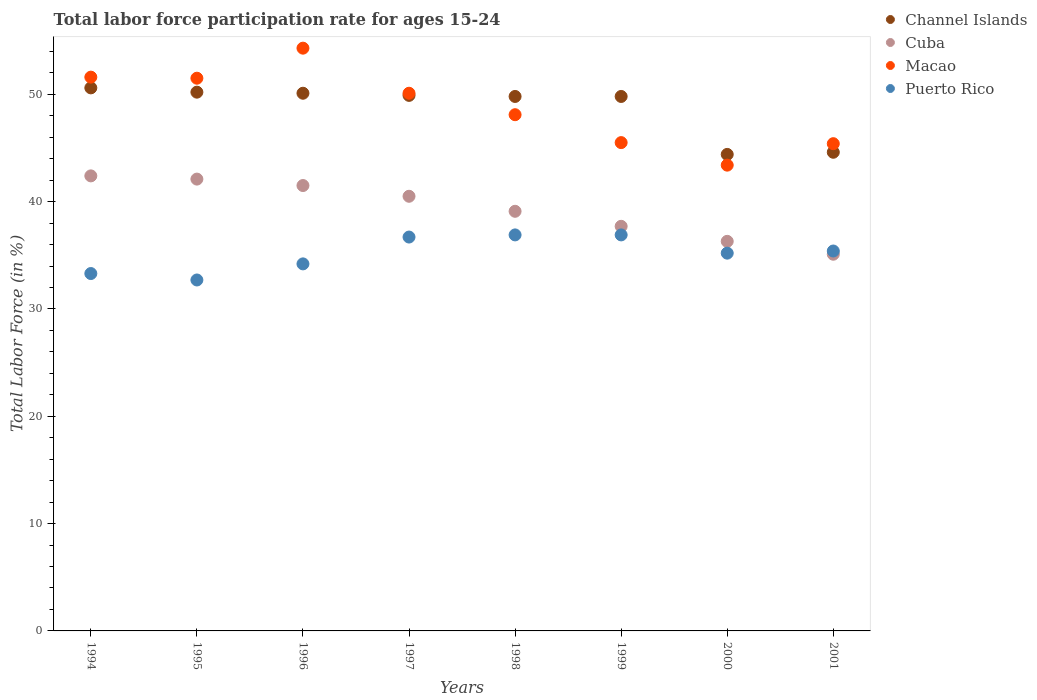Is the number of dotlines equal to the number of legend labels?
Make the answer very short. Yes. What is the labor force participation rate in Puerto Rico in 2001?
Provide a short and direct response. 35.4. Across all years, what is the maximum labor force participation rate in Cuba?
Your answer should be very brief. 42.4. Across all years, what is the minimum labor force participation rate in Macao?
Provide a short and direct response. 43.4. What is the total labor force participation rate in Channel Islands in the graph?
Offer a terse response. 389.4. What is the difference between the labor force participation rate in Macao in 1995 and that in 1997?
Provide a short and direct response. 1.4. What is the difference between the labor force participation rate in Channel Islands in 2000 and the labor force participation rate in Cuba in 2001?
Your answer should be very brief. 9.3. What is the average labor force participation rate in Cuba per year?
Provide a succinct answer. 39.34. In how many years, is the labor force participation rate in Puerto Rico greater than 38 %?
Ensure brevity in your answer.  0. What is the ratio of the labor force participation rate in Channel Islands in 1994 to that in 1997?
Offer a very short reply. 1.01. Is the difference between the labor force participation rate in Cuba in 1995 and 1996 greater than the difference between the labor force participation rate in Macao in 1995 and 1996?
Ensure brevity in your answer.  Yes. What is the difference between the highest and the lowest labor force participation rate in Puerto Rico?
Give a very brief answer. 4.2. Is it the case that in every year, the sum of the labor force participation rate in Macao and labor force participation rate in Puerto Rico  is greater than the sum of labor force participation rate in Channel Islands and labor force participation rate in Cuba?
Offer a terse response. No. Does the labor force participation rate in Cuba monotonically increase over the years?
Make the answer very short. No. Is the labor force participation rate in Cuba strictly less than the labor force participation rate in Channel Islands over the years?
Your answer should be very brief. Yes. How many dotlines are there?
Ensure brevity in your answer.  4. How many years are there in the graph?
Your response must be concise. 8. Does the graph contain any zero values?
Provide a short and direct response. No. What is the title of the graph?
Ensure brevity in your answer.  Total labor force participation rate for ages 15-24. What is the label or title of the Y-axis?
Ensure brevity in your answer.  Total Labor Force (in %). What is the Total Labor Force (in %) in Channel Islands in 1994?
Make the answer very short. 50.6. What is the Total Labor Force (in %) in Cuba in 1994?
Your answer should be compact. 42.4. What is the Total Labor Force (in %) in Macao in 1994?
Give a very brief answer. 51.6. What is the Total Labor Force (in %) of Puerto Rico in 1994?
Keep it short and to the point. 33.3. What is the Total Labor Force (in %) in Channel Islands in 1995?
Offer a very short reply. 50.2. What is the Total Labor Force (in %) of Cuba in 1995?
Your answer should be very brief. 42.1. What is the Total Labor Force (in %) of Macao in 1995?
Ensure brevity in your answer.  51.5. What is the Total Labor Force (in %) in Puerto Rico in 1995?
Ensure brevity in your answer.  32.7. What is the Total Labor Force (in %) of Channel Islands in 1996?
Provide a succinct answer. 50.1. What is the Total Labor Force (in %) in Cuba in 1996?
Offer a very short reply. 41.5. What is the Total Labor Force (in %) in Macao in 1996?
Ensure brevity in your answer.  54.3. What is the Total Labor Force (in %) of Puerto Rico in 1996?
Offer a very short reply. 34.2. What is the Total Labor Force (in %) of Channel Islands in 1997?
Your response must be concise. 49.9. What is the Total Labor Force (in %) of Cuba in 1997?
Make the answer very short. 40.5. What is the Total Labor Force (in %) in Macao in 1997?
Provide a succinct answer. 50.1. What is the Total Labor Force (in %) in Puerto Rico in 1997?
Your response must be concise. 36.7. What is the Total Labor Force (in %) in Channel Islands in 1998?
Give a very brief answer. 49.8. What is the Total Labor Force (in %) of Cuba in 1998?
Give a very brief answer. 39.1. What is the Total Labor Force (in %) of Macao in 1998?
Provide a succinct answer. 48.1. What is the Total Labor Force (in %) in Puerto Rico in 1998?
Provide a short and direct response. 36.9. What is the Total Labor Force (in %) in Channel Islands in 1999?
Your answer should be very brief. 49.8. What is the Total Labor Force (in %) in Cuba in 1999?
Ensure brevity in your answer.  37.7. What is the Total Labor Force (in %) of Macao in 1999?
Offer a terse response. 45.5. What is the Total Labor Force (in %) in Puerto Rico in 1999?
Ensure brevity in your answer.  36.9. What is the Total Labor Force (in %) of Channel Islands in 2000?
Ensure brevity in your answer.  44.4. What is the Total Labor Force (in %) in Cuba in 2000?
Your answer should be very brief. 36.3. What is the Total Labor Force (in %) of Macao in 2000?
Your response must be concise. 43.4. What is the Total Labor Force (in %) of Puerto Rico in 2000?
Provide a short and direct response. 35.2. What is the Total Labor Force (in %) of Channel Islands in 2001?
Provide a short and direct response. 44.6. What is the Total Labor Force (in %) of Cuba in 2001?
Ensure brevity in your answer.  35.1. What is the Total Labor Force (in %) of Macao in 2001?
Your answer should be compact. 45.4. What is the Total Labor Force (in %) in Puerto Rico in 2001?
Keep it short and to the point. 35.4. Across all years, what is the maximum Total Labor Force (in %) in Channel Islands?
Make the answer very short. 50.6. Across all years, what is the maximum Total Labor Force (in %) in Cuba?
Give a very brief answer. 42.4. Across all years, what is the maximum Total Labor Force (in %) of Macao?
Your answer should be compact. 54.3. Across all years, what is the maximum Total Labor Force (in %) in Puerto Rico?
Provide a short and direct response. 36.9. Across all years, what is the minimum Total Labor Force (in %) of Channel Islands?
Your response must be concise. 44.4. Across all years, what is the minimum Total Labor Force (in %) of Cuba?
Give a very brief answer. 35.1. Across all years, what is the minimum Total Labor Force (in %) of Macao?
Your answer should be compact. 43.4. Across all years, what is the minimum Total Labor Force (in %) in Puerto Rico?
Your response must be concise. 32.7. What is the total Total Labor Force (in %) of Channel Islands in the graph?
Your answer should be compact. 389.4. What is the total Total Labor Force (in %) in Cuba in the graph?
Your answer should be very brief. 314.7. What is the total Total Labor Force (in %) in Macao in the graph?
Your answer should be compact. 389.9. What is the total Total Labor Force (in %) in Puerto Rico in the graph?
Offer a terse response. 281.3. What is the difference between the Total Labor Force (in %) in Channel Islands in 1994 and that in 1995?
Give a very brief answer. 0.4. What is the difference between the Total Labor Force (in %) in Cuba in 1994 and that in 1995?
Your response must be concise. 0.3. What is the difference between the Total Labor Force (in %) of Puerto Rico in 1994 and that in 1995?
Your response must be concise. 0.6. What is the difference between the Total Labor Force (in %) of Cuba in 1994 and that in 1996?
Give a very brief answer. 0.9. What is the difference between the Total Labor Force (in %) of Macao in 1994 and that in 1996?
Your answer should be very brief. -2.7. What is the difference between the Total Labor Force (in %) in Puerto Rico in 1994 and that in 1996?
Your answer should be compact. -0.9. What is the difference between the Total Labor Force (in %) of Cuba in 1994 and that in 1997?
Keep it short and to the point. 1.9. What is the difference between the Total Labor Force (in %) in Puerto Rico in 1994 and that in 1997?
Your answer should be very brief. -3.4. What is the difference between the Total Labor Force (in %) in Channel Islands in 1994 and that in 1998?
Offer a terse response. 0.8. What is the difference between the Total Labor Force (in %) of Cuba in 1994 and that in 1998?
Make the answer very short. 3.3. What is the difference between the Total Labor Force (in %) in Macao in 1994 and that in 1998?
Make the answer very short. 3.5. What is the difference between the Total Labor Force (in %) in Cuba in 1994 and that in 1999?
Your response must be concise. 4.7. What is the difference between the Total Labor Force (in %) of Puerto Rico in 1994 and that in 1999?
Ensure brevity in your answer.  -3.6. What is the difference between the Total Labor Force (in %) in Channel Islands in 1994 and that in 2000?
Your answer should be compact. 6.2. What is the difference between the Total Labor Force (in %) of Puerto Rico in 1994 and that in 2000?
Your answer should be compact. -1.9. What is the difference between the Total Labor Force (in %) in Puerto Rico in 1994 and that in 2001?
Your response must be concise. -2.1. What is the difference between the Total Labor Force (in %) in Cuba in 1995 and that in 1996?
Your response must be concise. 0.6. What is the difference between the Total Labor Force (in %) in Macao in 1995 and that in 1996?
Offer a very short reply. -2.8. What is the difference between the Total Labor Force (in %) in Channel Islands in 1995 and that in 1997?
Offer a terse response. 0.3. What is the difference between the Total Labor Force (in %) of Cuba in 1995 and that in 1997?
Your answer should be very brief. 1.6. What is the difference between the Total Labor Force (in %) in Puerto Rico in 1995 and that in 1997?
Provide a short and direct response. -4. What is the difference between the Total Labor Force (in %) in Cuba in 1995 and that in 1998?
Your response must be concise. 3. What is the difference between the Total Labor Force (in %) of Puerto Rico in 1995 and that in 1998?
Give a very brief answer. -4.2. What is the difference between the Total Labor Force (in %) in Cuba in 1995 and that in 1999?
Provide a succinct answer. 4.4. What is the difference between the Total Labor Force (in %) of Channel Islands in 1995 and that in 2000?
Your answer should be very brief. 5.8. What is the difference between the Total Labor Force (in %) of Cuba in 1995 and that in 2000?
Your answer should be very brief. 5.8. What is the difference between the Total Labor Force (in %) in Macao in 1995 and that in 2000?
Your response must be concise. 8.1. What is the difference between the Total Labor Force (in %) of Channel Islands in 1995 and that in 2001?
Provide a succinct answer. 5.6. What is the difference between the Total Labor Force (in %) in Puerto Rico in 1995 and that in 2001?
Provide a succinct answer. -2.7. What is the difference between the Total Labor Force (in %) of Channel Islands in 1996 and that in 1997?
Provide a succinct answer. 0.2. What is the difference between the Total Labor Force (in %) of Puerto Rico in 1996 and that in 1997?
Make the answer very short. -2.5. What is the difference between the Total Labor Force (in %) in Channel Islands in 1996 and that in 1998?
Your response must be concise. 0.3. What is the difference between the Total Labor Force (in %) in Macao in 1996 and that in 1998?
Provide a succinct answer. 6.2. What is the difference between the Total Labor Force (in %) of Macao in 1996 and that in 1999?
Make the answer very short. 8.8. What is the difference between the Total Labor Force (in %) in Channel Islands in 1996 and that in 2000?
Make the answer very short. 5.7. What is the difference between the Total Labor Force (in %) of Cuba in 1996 and that in 2000?
Provide a succinct answer. 5.2. What is the difference between the Total Labor Force (in %) in Puerto Rico in 1996 and that in 2000?
Provide a succinct answer. -1. What is the difference between the Total Labor Force (in %) of Puerto Rico in 1996 and that in 2001?
Your answer should be compact. -1.2. What is the difference between the Total Labor Force (in %) in Channel Islands in 1997 and that in 1998?
Offer a terse response. 0.1. What is the difference between the Total Labor Force (in %) in Cuba in 1997 and that in 1998?
Provide a short and direct response. 1.4. What is the difference between the Total Labor Force (in %) in Macao in 1997 and that in 1998?
Make the answer very short. 2. What is the difference between the Total Labor Force (in %) in Puerto Rico in 1997 and that in 1998?
Provide a short and direct response. -0.2. What is the difference between the Total Labor Force (in %) of Puerto Rico in 1997 and that in 1999?
Provide a short and direct response. -0.2. What is the difference between the Total Labor Force (in %) in Macao in 1997 and that in 2000?
Your answer should be very brief. 6.7. What is the difference between the Total Labor Force (in %) in Channel Islands in 1997 and that in 2001?
Provide a succinct answer. 5.3. What is the difference between the Total Labor Force (in %) in Cuba in 1997 and that in 2001?
Offer a terse response. 5.4. What is the difference between the Total Labor Force (in %) of Puerto Rico in 1997 and that in 2001?
Offer a very short reply. 1.3. What is the difference between the Total Labor Force (in %) in Channel Islands in 1998 and that in 1999?
Offer a very short reply. 0. What is the difference between the Total Labor Force (in %) of Macao in 1998 and that in 1999?
Offer a very short reply. 2.6. What is the difference between the Total Labor Force (in %) in Puerto Rico in 1998 and that in 1999?
Make the answer very short. 0. What is the difference between the Total Labor Force (in %) in Channel Islands in 1998 and that in 2000?
Provide a short and direct response. 5.4. What is the difference between the Total Labor Force (in %) of Macao in 1998 and that in 2000?
Your response must be concise. 4.7. What is the difference between the Total Labor Force (in %) in Puerto Rico in 1998 and that in 2000?
Provide a succinct answer. 1.7. What is the difference between the Total Labor Force (in %) in Channel Islands in 1998 and that in 2001?
Offer a very short reply. 5.2. What is the difference between the Total Labor Force (in %) in Puerto Rico in 1998 and that in 2001?
Your answer should be compact. 1.5. What is the difference between the Total Labor Force (in %) in Puerto Rico in 1999 and that in 2001?
Ensure brevity in your answer.  1.5. What is the difference between the Total Labor Force (in %) of Channel Islands in 2000 and that in 2001?
Ensure brevity in your answer.  -0.2. What is the difference between the Total Labor Force (in %) of Channel Islands in 1994 and the Total Labor Force (in %) of Macao in 1995?
Offer a very short reply. -0.9. What is the difference between the Total Labor Force (in %) of Cuba in 1994 and the Total Labor Force (in %) of Macao in 1995?
Provide a short and direct response. -9.1. What is the difference between the Total Labor Force (in %) of Channel Islands in 1994 and the Total Labor Force (in %) of Cuba in 1996?
Make the answer very short. 9.1. What is the difference between the Total Labor Force (in %) of Channel Islands in 1994 and the Total Labor Force (in %) of Puerto Rico in 1996?
Give a very brief answer. 16.4. What is the difference between the Total Labor Force (in %) in Cuba in 1994 and the Total Labor Force (in %) in Puerto Rico in 1996?
Your response must be concise. 8.2. What is the difference between the Total Labor Force (in %) of Cuba in 1994 and the Total Labor Force (in %) of Macao in 1997?
Your answer should be very brief. -7.7. What is the difference between the Total Labor Force (in %) in Channel Islands in 1994 and the Total Labor Force (in %) in Cuba in 1998?
Ensure brevity in your answer.  11.5. What is the difference between the Total Labor Force (in %) in Channel Islands in 1994 and the Total Labor Force (in %) in Macao in 1998?
Your response must be concise. 2.5. What is the difference between the Total Labor Force (in %) of Channel Islands in 1994 and the Total Labor Force (in %) of Puerto Rico in 1998?
Your answer should be compact. 13.7. What is the difference between the Total Labor Force (in %) of Cuba in 1994 and the Total Labor Force (in %) of Macao in 1998?
Offer a terse response. -5.7. What is the difference between the Total Labor Force (in %) of Cuba in 1994 and the Total Labor Force (in %) of Macao in 1999?
Keep it short and to the point. -3.1. What is the difference between the Total Labor Force (in %) in Cuba in 1994 and the Total Labor Force (in %) in Puerto Rico in 1999?
Your response must be concise. 5.5. What is the difference between the Total Labor Force (in %) in Macao in 1994 and the Total Labor Force (in %) in Puerto Rico in 1999?
Offer a terse response. 14.7. What is the difference between the Total Labor Force (in %) of Cuba in 1994 and the Total Labor Force (in %) of Macao in 2000?
Provide a succinct answer. -1. What is the difference between the Total Labor Force (in %) in Macao in 1994 and the Total Labor Force (in %) in Puerto Rico in 2000?
Offer a very short reply. 16.4. What is the difference between the Total Labor Force (in %) of Channel Islands in 1994 and the Total Labor Force (in %) of Puerto Rico in 2001?
Offer a very short reply. 15.2. What is the difference between the Total Labor Force (in %) in Cuba in 1994 and the Total Labor Force (in %) in Macao in 2001?
Provide a short and direct response. -3. What is the difference between the Total Labor Force (in %) of Macao in 1994 and the Total Labor Force (in %) of Puerto Rico in 2001?
Make the answer very short. 16.2. What is the difference between the Total Labor Force (in %) in Channel Islands in 1995 and the Total Labor Force (in %) in Cuba in 1996?
Your response must be concise. 8.7. What is the difference between the Total Labor Force (in %) in Macao in 1995 and the Total Labor Force (in %) in Puerto Rico in 1996?
Keep it short and to the point. 17.3. What is the difference between the Total Labor Force (in %) in Cuba in 1995 and the Total Labor Force (in %) in Puerto Rico in 1997?
Offer a very short reply. 5.4. What is the difference between the Total Labor Force (in %) in Macao in 1995 and the Total Labor Force (in %) in Puerto Rico in 1997?
Provide a succinct answer. 14.8. What is the difference between the Total Labor Force (in %) of Channel Islands in 1995 and the Total Labor Force (in %) of Puerto Rico in 1998?
Offer a terse response. 13.3. What is the difference between the Total Labor Force (in %) of Macao in 1995 and the Total Labor Force (in %) of Puerto Rico in 1998?
Provide a succinct answer. 14.6. What is the difference between the Total Labor Force (in %) in Channel Islands in 1995 and the Total Labor Force (in %) in Macao in 1999?
Give a very brief answer. 4.7. What is the difference between the Total Labor Force (in %) in Channel Islands in 1995 and the Total Labor Force (in %) in Puerto Rico in 1999?
Provide a short and direct response. 13.3. What is the difference between the Total Labor Force (in %) of Cuba in 1995 and the Total Labor Force (in %) of Puerto Rico in 1999?
Provide a succinct answer. 5.2. What is the difference between the Total Labor Force (in %) of Channel Islands in 1995 and the Total Labor Force (in %) of Puerto Rico in 2000?
Your answer should be very brief. 15. What is the difference between the Total Labor Force (in %) in Channel Islands in 1995 and the Total Labor Force (in %) in Cuba in 2001?
Keep it short and to the point. 15.1. What is the difference between the Total Labor Force (in %) of Cuba in 1995 and the Total Labor Force (in %) of Puerto Rico in 2001?
Offer a terse response. 6.7. What is the difference between the Total Labor Force (in %) of Macao in 1995 and the Total Labor Force (in %) of Puerto Rico in 2001?
Provide a succinct answer. 16.1. What is the difference between the Total Labor Force (in %) in Channel Islands in 1996 and the Total Labor Force (in %) in Cuba in 1997?
Offer a terse response. 9.6. What is the difference between the Total Labor Force (in %) in Cuba in 1996 and the Total Labor Force (in %) in Puerto Rico in 1997?
Offer a terse response. 4.8. What is the difference between the Total Labor Force (in %) in Channel Islands in 1996 and the Total Labor Force (in %) in Macao in 1998?
Give a very brief answer. 2. What is the difference between the Total Labor Force (in %) of Cuba in 1996 and the Total Labor Force (in %) of Puerto Rico in 1998?
Give a very brief answer. 4.6. What is the difference between the Total Labor Force (in %) of Channel Islands in 1996 and the Total Labor Force (in %) of Cuba in 1999?
Offer a terse response. 12.4. What is the difference between the Total Labor Force (in %) of Cuba in 1996 and the Total Labor Force (in %) of Macao in 1999?
Offer a terse response. -4. What is the difference between the Total Labor Force (in %) in Channel Islands in 1996 and the Total Labor Force (in %) in Macao in 2000?
Your answer should be compact. 6.7. What is the difference between the Total Labor Force (in %) of Cuba in 1996 and the Total Labor Force (in %) of Puerto Rico in 2000?
Ensure brevity in your answer.  6.3. What is the difference between the Total Labor Force (in %) of Macao in 1996 and the Total Labor Force (in %) of Puerto Rico in 2000?
Provide a succinct answer. 19.1. What is the difference between the Total Labor Force (in %) of Channel Islands in 1996 and the Total Labor Force (in %) of Cuba in 2001?
Make the answer very short. 15. What is the difference between the Total Labor Force (in %) in Channel Islands in 1996 and the Total Labor Force (in %) in Puerto Rico in 2001?
Your answer should be very brief. 14.7. What is the difference between the Total Labor Force (in %) in Cuba in 1996 and the Total Labor Force (in %) in Puerto Rico in 2001?
Provide a succinct answer. 6.1. What is the difference between the Total Labor Force (in %) of Channel Islands in 1997 and the Total Labor Force (in %) of Cuba in 1998?
Your response must be concise. 10.8. What is the difference between the Total Labor Force (in %) in Channel Islands in 1997 and the Total Labor Force (in %) in Macao in 1998?
Give a very brief answer. 1.8. What is the difference between the Total Labor Force (in %) of Macao in 1997 and the Total Labor Force (in %) of Puerto Rico in 1998?
Provide a short and direct response. 13.2. What is the difference between the Total Labor Force (in %) of Channel Islands in 1997 and the Total Labor Force (in %) of Macao in 1999?
Keep it short and to the point. 4.4. What is the difference between the Total Labor Force (in %) of Cuba in 1997 and the Total Labor Force (in %) of Macao in 1999?
Your answer should be compact. -5. What is the difference between the Total Labor Force (in %) of Channel Islands in 1997 and the Total Labor Force (in %) of Cuba in 2000?
Your answer should be compact. 13.6. What is the difference between the Total Labor Force (in %) of Channel Islands in 1997 and the Total Labor Force (in %) of Macao in 2000?
Provide a short and direct response. 6.5. What is the difference between the Total Labor Force (in %) in Channel Islands in 1997 and the Total Labor Force (in %) in Puerto Rico in 2000?
Your response must be concise. 14.7. What is the difference between the Total Labor Force (in %) in Channel Islands in 1997 and the Total Labor Force (in %) in Cuba in 2001?
Ensure brevity in your answer.  14.8. What is the difference between the Total Labor Force (in %) in Channel Islands in 1997 and the Total Labor Force (in %) in Macao in 2001?
Provide a short and direct response. 4.5. What is the difference between the Total Labor Force (in %) in Channel Islands in 1997 and the Total Labor Force (in %) in Puerto Rico in 2001?
Offer a very short reply. 14.5. What is the difference between the Total Labor Force (in %) of Channel Islands in 1998 and the Total Labor Force (in %) of Puerto Rico in 1999?
Offer a very short reply. 12.9. What is the difference between the Total Labor Force (in %) of Cuba in 1998 and the Total Labor Force (in %) of Macao in 1999?
Your answer should be very brief. -6.4. What is the difference between the Total Labor Force (in %) in Cuba in 1998 and the Total Labor Force (in %) in Macao in 2000?
Offer a very short reply. -4.3. What is the difference between the Total Labor Force (in %) of Macao in 1998 and the Total Labor Force (in %) of Puerto Rico in 2000?
Offer a very short reply. 12.9. What is the difference between the Total Labor Force (in %) of Channel Islands in 1998 and the Total Labor Force (in %) of Cuba in 2001?
Provide a succinct answer. 14.7. What is the difference between the Total Labor Force (in %) in Channel Islands in 1998 and the Total Labor Force (in %) in Macao in 2001?
Your answer should be very brief. 4.4. What is the difference between the Total Labor Force (in %) of Channel Islands in 1998 and the Total Labor Force (in %) of Puerto Rico in 2001?
Ensure brevity in your answer.  14.4. What is the difference between the Total Labor Force (in %) in Cuba in 1998 and the Total Labor Force (in %) in Macao in 2001?
Make the answer very short. -6.3. What is the difference between the Total Labor Force (in %) in Cuba in 1998 and the Total Labor Force (in %) in Puerto Rico in 2001?
Provide a succinct answer. 3.7. What is the difference between the Total Labor Force (in %) of Channel Islands in 1999 and the Total Labor Force (in %) of Cuba in 2000?
Give a very brief answer. 13.5. What is the difference between the Total Labor Force (in %) in Channel Islands in 1999 and the Total Labor Force (in %) in Macao in 2000?
Give a very brief answer. 6.4. What is the difference between the Total Labor Force (in %) in Macao in 1999 and the Total Labor Force (in %) in Puerto Rico in 2000?
Keep it short and to the point. 10.3. What is the difference between the Total Labor Force (in %) in Channel Islands in 1999 and the Total Labor Force (in %) in Cuba in 2001?
Your answer should be very brief. 14.7. What is the difference between the Total Labor Force (in %) in Cuba in 1999 and the Total Labor Force (in %) in Macao in 2001?
Give a very brief answer. -7.7. What is the difference between the Total Labor Force (in %) of Macao in 1999 and the Total Labor Force (in %) of Puerto Rico in 2001?
Keep it short and to the point. 10.1. What is the difference between the Total Labor Force (in %) of Channel Islands in 2000 and the Total Labor Force (in %) of Puerto Rico in 2001?
Give a very brief answer. 9. What is the difference between the Total Labor Force (in %) of Macao in 2000 and the Total Labor Force (in %) of Puerto Rico in 2001?
Provide a short and direct response. 8. What is the average Total Labor Force (in %) of Channel Islands per year?
Your answer should be compact. 48.67. What is the average Total Labor Force (in %) in Cuba per year?
Provide a short and direct response. 39.34. What is the average Total Labor Force (in %) in Macao per year?
Provide a succinct answer. 48.74. What is the average Total Labor Force (in %) in Puerto Rico per year?
Provide a short and direct response. 35.16. In the year 1994, what is the difference between the Total Labor Force (in %) in Cuba and Total Labor Force (in %) in Puerto Rico?
Your answer should be compact. 9.1. In the year 1994, what is the difference between the Total Labor Force (in %) of Macao and Total Labor Force (in %) of Puerto Rico?
Your response must be concise. 18.3. In the year 1995, what is the difference between the Total Labor Force (in %) in Channel Islands and Total Labor Force (in %) in Macao?
Give a very brief answer. -1.3. In the year 1995, what is the difference between the Total Labor Force (in %) in Channel Islands and Total Labor Force (in %) in Puerto Rico?
Offer a terse response. 17.5. In the year 1995, what is the difference between the Total Labor Force (in %) of Cuba and Total Labor Force (in %) of Puerto Rico?
Ensure brevity in your answer.  9.4. In the year 1996, what is the difference between the Total Labor Force (in %) in Channel Islands and Total Labor Force (in %) in Puerto Rico?
Ensure brevity in your answer.  15.9. In the year 1996, what is the difference between the Total Labor Force (in %) of Cuba and Total Labor Force (in %) of Macao?
Provide a short and direct response. -12.8. In the year 1996, what is the difference between the Total Labor Force (in %) in Macao and Total Labor Force (in %) in Puerto Rico?
Offer a very short reply. 20.1. In the year 1997, what is the difference between the Total Labor Force (in %) in Channel Islands and Total Labor Force (in %) in Cuba?
Give a very brief answer. 9.4. In the year 1997, what is the difference between the Total Labor Force (in %) in Channel Islands and Total Labor Force (in %) in Macao?
Provide a short and direct response. -0.2. In the year 1997, what is the difference between the Total Labor Force (in %) of Channel Islands and Total Labor Force (in %) of Puerto Rico?
Provide a short and direct response. 13.2. In the year 1997, what is the difference between the Total Labor Force (in %) in Macao and Total Labor Force (in %) in Puerto Rico?
Give a very brief answer. 13.4. In the year 1998, what is the difference between the Total Labor Force (in %) in Channel Islands and Total Labor Force (in %) in Macao?
Give a very brief answer. 1.7. In the year 1998, what is the difference between the Total Labor Force (in %) in Cuba and Total Labor Force (in %) in Puerto Rico?
Your answer should be very brief. 2.2. In the year 1998, what is the difference between the Total Labor Force (in %) in Macao and Total Labor Force (in %) in Puerto Rico?
Your answer should be very brief. 11.2. In the year 1999, what is the difference between the Total Labor Force (in %) of Channel Islands and Total Labor Force (in %) of Macao?
Provide a succinct answer. 4.3. In the year 1999, what is the difference between the Total Labor Force (in %) in Channel Islands and Total Labor Force (in %) in Puerto Rico?
Your response must be concise. 12.9. In the year 1999, what is the difference between the Total Labor Force (in %) in Cuba and Total Labor Force (in %) in Puerto Rico?
Your answer should be very brief. 0.8. In the year 2000, what is the difference between the Total Labor Force (in %) of Channel Islands and Total Labor Force (in %) of Cuba?
Ensure brevity in your answer.  8.1. In the year 2000, what is the difference between the Total Labor Force (in %) in Cuba and Total Labor Force (in %) in Puerto Rico?
Offer a very short reply. 1.1. In the year 2000, what is the difference between the Total Labor Force (in %) in Macao and Total Labor Force (in %) in Puerto Rico?
Give a very brief answer. 8.2. In the year 2001, what is the difference between the Total Labor Force (in %) of Channel Islands and Total Labor Force (in %) of Cuba?
Provide a succinct answer. 9.5. In the year 2001, what is the difference between the Total Labor Force (in %) in Cuba and Total Labor Force (in %) in Macao?
Keep it short and to the point. -10.3. What is the ratio of the Total Labor Force (in %) in Cuba in 1994 to that in 1995?
Your response must be concise. 1.01. What is the ratio of the Total Labor Force (in %) of Puerto Rico in 1994 to that in 1995?
Provide a succinct answer. 1.02. What is the ratio of the Total Labor Force (in %) of Channel Islands in 1994 to that in 1996?
Provide a short and direct response. 1.01. What is the ratio of the Total Labor Force (in %) in Cuba in 1994 to that in 1996?
Keep it short and to the point. 1.02. What is the ratio of the Total Labor Force (in %) of Macao in 1994 to that in 1996?
Your response must be concise. 0.95. What is the ratio of the Total Labor Force (in %) of Puerto Rico in 1994 to that in 1996?
Your answer should be compact. 0.97. What is the ratio of the Total Labor Force (in %) in Channel Islands in 1994 to that in 1997?
Your answer should be compact. 1.01. What is the ratio of the Total Labor Force (in %) in Cuba in 1994 to that in 1997?
Make the answer very short. 1.05. What is the ratio of the Total Labor Force (in %) in Macao in 1994 to that in 1997?
Offer a terse response. 1.03. What is the ratio of the Total Labor Force (in %) of Puerto Rico in 1994 to that in 1997?
Offer a very short reply. 0.91. What is the ratio of the Total Labor Force (in %) of Channel Islands in 1994 to that in 1998?
Keep it short and to the point. 1.02. What is the ratio of the Total Labor Force (in %) in Cuba in 1994 to that in 1998?
Give a very brief answer. 1.08. What is the ratio of the Total Labor Force (in %) in Macao in 1994 to that in 1998?
Your answer should be very brief. 1.07. What is the ratio of the Total Labor Force (in %) in Puerto Rico in 1994 to that in 1998?
Offer a very short reply. 0.9. What is the ratio of the Total Labor Force (in %) in Channel Islands in 1994 to that in 1999?
Your answer should be very brief. 1.02. What is the ratio of the Total Labor Force (in %) of Cuba in 1994 to that in 1999?
Make the answer very short. 1.12. What is the ratio of the Total Labor Force (in %) of Macao in 1994 to that in 1999?
Your answer should be compact. 1.13. What is the ratio of the Total Labor Force (in %) of Puerto Rico in 1994 to that in 1999?
Provide a short and direct response. 0.9. What is the ratio of the Total Labor Force (in %) of Channel Islands in 1994 to that in 2000?
Ensure brevity in your answer.  1.14. What is the ratio of the Total Labor Force (in %) of Cuba in 1994 to that in 2000?
Offer a very short reply. 1.17. What is the ratio of the Total Labor Force (in %) of Macao in 1994 to that in 2000?
Your answer should be very brief. 1.19. What is the ratio of the Total Labor Force (in %) of Puerto Rico in 1994 to that in 2000?
Your answer should be compact. 0.95. What is the ratio of the Total Labor Force (in %) in Channel Islands in 1994 to that in 2001?
Offer a terse response. 1.13. What is the ratio of the Total Labor Force (in %) in Cuba in 1994 to that in 2001?
Ensure brevity in your answer.  1.21. What is the ratio of the Total Labor Force (in %) of Macao in 1994 to that in 2001?
Keep it short and to the point. 1.14. What is the ratio of the Total Labor Force (in %) of Puerto Rico in 1994 to that in 2001?
Your response must be concise. 0.94. What is the ratio of the Total Labor Force (in %) of Cuba in 1995 to that in 1996?
Provide a succinct answer. 1.01. What is the ratio of the Total Labor Force (in %) in Macao in 1995 to that in 1996?
Provide a succinct answer. 0.95. What is the ratio of the Total Labor Force (in %) of Puerto Rico in 1995 to that in 1996?
Your answer should be very brief. 0.96. What is the ratio of the Total Labor Force (in %) of Channel Islands in 1995 to that in 1997?
Provide a short and direct response. 1.01. What is the ratio of the Total Labor Force (in %) of Cuba in 1995 to that in 1997?
Make the answer very short. 1.04. What is the ratio of the Total Labor Force (in %) of Macao in 1995 to that in 1997?
Offer a terse response. 1.03. What is the ratio of the Total Labor Force (in %) in Puerto Rico in 1995 to that in 1997?
Your answer should be compact. 0.89. What is the ratio of the Total Labor Force (in %) of Channel Islands in 1995 to that in 1998?
Make the answer very short. 1.01. What is the ratio of the Total Labor Force (in %) of Cuba in 1995 to that in 1998?
Offer a very short reply. 1.08. What is the ratio of the Total Labor Force (in %) of Macao in 1995 to that in 1998?
Provide a succinct answer. 1.07. What is the ratio of the Total Labor Force (in %) in Puerto Rico in 1995 to that in 1998?
Your response must be concise. 0.89. What is the ratio of the Total Labor Force (in %) of Cuba in 1995 to that in 1999?
Provide a short and direct response. 1.12. What is the ratio of the Total Labor Force (in %) in Macao in 1995 to that in 1999?
Ensure brevity in your answer.  1.13. What is the ratio of the Total Labor Force (in %) in Puerto Rico in 1995 to that in 1999?
Your answer should be compact. 0.89. What is the ratio of the Total Labor Force (in %) of Channel Islands in 1995 to that in 2000?
Make the answer very short. 1.13. What is the ratio of the Total Labor Force (in %) in Cuba in 1995 to that in 2000?
Your response must be concise. 1.16. What is the ratio of the Total Labor Force (in %) in Macao in 1995 to that in 2000?
Provide a succinct answer. 1.19. What is the ratio of the Total Labor Force (in %) in Puerto Rico in 1995 to that in 2000?
Make the answer very short. 0.93. What is the ratio of the Total Labor Force (in %) of Channel Islands in 1995 to that in 2001?
Keep it short and to the point. 1.13. What is the ratio of the Total Labor Force (in %) in Cuba in 1995 to that in 2001?
Your answer should be compact. 1.2. What is the ratio of the Total Labor Force (in %) in Macao in 1995 to that in 2001?
Keep it short and to the point. 1.13. What is the ratio of the Total Labor Force (in %) of Puerto Rico in 1995 to that in 2001?
Make the answer very short. 0.92. What is the ratio of the Total Labor Force (in %) of Cuba in 1996 to that in 1997?
Offer a very short reply. 1.02. What is the ratio of the Total Labor Force (in %) in Macao in 1996 to that in 1997?
Ensure brevity in your answer.  1.08. What is the ratio of the Total Labor Force (in %) in Puerto Rico in 1996 to that in 1997?
Offer a terse response. 0.93. What is the ratio of the Total Labor Force (in %) of Cuba in 1996 to that in 1998?
Provide a succinct answer. 1.06. What is the ratio of the Total Labor Force (in %) in Macao in 1996 to that in 1998?
Your response must be concise. 1.13. What is the ratio of the Total Labor Force (in %) in Puerto Rico in 1996 to that in 1998?
Your response must be concise. 0.93. What is the ratio of the Total Labor Force (in %) of Cuba in 1996 to that in 1999?
Ensure brevity in your answer.  1.1. What is the ratio of the Total Labor Force (in %) in Macao in 1996 to that in 1999?
Provide a succinct answer. 1.19. What is the ratio of the Total Labor Force (in %) of Puerto Rico in 1996 to that in 1999?
Ensure brevity in your answer.  0.93. What is the ratio of the Total Labor Force (in %) in Channel Islands in 1996 to that in 2000?
Your answer should be very brief. 1.13. What is the ratio of the Total Labor Force (in %) in Cuba in 1996 to that in 2000?
Offer a terse response. 1.14. What is the ratio of the Total Labor Force (in %) in Macao in 1996 to that in 2000?
Keep it short and to the point. 1.25. What is the ratio of the Total Labor Force (in %) in Puerto Rico in 1996 to that in 2000?
Make the answer very short. 0.97. What is the ratio of the Total Labor Force (in %) in Channel Islands in 1996 to that in 2001?
Give a very brief answer. 1.12. What is the ratio of the Total Labor Force (in %) in Cuba in 1996 to that in 2001?
Your answer should be compact. 1.18. What is the ratio of the Total Labor Force (in %) in Macao in 1996 to that in 2001?
Your response must be concise. 1.2. What is the ratio of the Total Labor Force (in %) of Puerto Rico in 1996 to that in 2001?
Ensure brevity in your answer.  0.97. What is the ratio of the Total Labor Force (in %) of Cuba in 1997 to that in 1998?
Give a very brief answer. 1.04. What is the ratio of the Total Labor Force (in %) in Macao in 1997 to that in 1998?
Provide a short and direct response. 1.04. What is the ratio of the Total Labor Force (in %) in Channel Islands in 1997 to that in 1999?
Give a very brief answer. 1. What is the ratio of the Total Labor Force (in %) in Cuba in 1997 to that in 1999?
Offer a very short reply. 1.07. What is the ratio of the Total Labor Force (in %) of Macao in 1997 to that in 1999?
Make the answer very short. 1.1. What is the ratio of the Total Labor Force (in %) in Channel Islands in 1997 to that in 2000?
Keep it short and to the point. 1.12. What is the ratio of the Total Labor Force (in %) in Cuba in 1997 to that in 2000?
Make the answer very short. 1.12. What is the ratio of the Total Labor Force (in %) in Macao in 1997 to that in 2000?
Provide a short and direct response. 1.15. What is the ratio of the Total Labor Force (in %) in Puerto Rico in 1997 to that in 2000?
Provide a succinct answer. 1.04. What is the ratio of the Total Labor Force (in %) in Channel Islands in 1997 to that in 2001?
Offer a terse response. 1.12. What is the ratio of the Total Labor Force (in %) of Cuba in 1997 to that in 2001?
Offer a very short reply. 1.15. What is the ratio of the Total Labor Force (in %) in Macao in 1997 to that in 2001?
Your response must be concise. 1.1. What is the ratio of the Total Labor Force (in %) of Puerto Rico in 1997 to that in 2001?
Give a very brief answer. 1.04. What is the ratio of the Total Labor Force (in %) in Channel Islands in 1998 to that in 1999?
Your answer should be compact. 1. What is the ratio of the Total Labor Force (in %) in Cuba in 1998 to that in 1999?
Give a very brief answer. 1.04. What is the ratio of the Total Labor Force (in %) of Macao in 1998 to that in 1999?
Offer a very short reply. 1.06. What is the ratio of the Total Labor Force (in %) in Puerto Rico in 1998 to that in 1999?
Your answer should be compact. 1. What is the ratio of the Total Labor Force (in %) in Channel Islands in 1998 to that in 2000?
Provide a succinct answer. 1.12. What is the ratio of the Total Labor Force (in %) in Cuba in 1998 to that in 2000?
Your answer should be compact. 1.08. What is the ratio of the Total Labor Force (in %) in Macao in 1998 to that in 2000?
Make the answer very short. 1.11. What is the ratio of the Total Labor Force (in %) in Puerto Rico in 1998 to that in 2000?
Offer a very short reply. 1.05. What is the ratio of the Total Labor Force (in %) of Channel Islands in 1998 to that in 2001?
Provide a succinct answer. 1.12. What is the ratio of the Total Labor Force (in %) of Cuba in 1998 to that in 2001?
Offer a very short reply. 1.11. What is the ratio of the Total Labor Force (in %) in Macao in 1998 to that in 2001?
Your answer should be compact. 1.06. What is the ratio of the Total Labor Force (in %) in Puerto Rico in 1998 to that in 2001?
Keep it short and to the point. 1.04. What is the ratio of the Total Labor Force (in %) in Channel Islands in 1999 to that in 2000?
Make the answer very short. 1.12. What is the ratio of the Total Labor Force (in %) in Cuba in 1999 to that in 2000?
Your answer should be compact. 1.04. What is the ratio of the Total Labor Force (in %) of Macao in 1999 to that in 2000?
Give a very brief answer. 1.05. What is the ratio of the Total Labor Force (in %) of Puerto Rico in 1999 to that in 2000?
Keep it short and to the point. 1.05. What is the ratio of the Total Labor Force (in %) of Channel Islands in 1999 to that in 2001?
Your answer should be very brief. 1.12. What is the ratio of the Total Labor Force (in %) in Cuba in 1999 to that in 2001?
Provide a succinct answer. 1.07. What is the ratio of the Total Labor Force (in %) in Macao in 1999 to that in 2001?
Keep it short and to the point. 1. What is the ratio of the Total Labor Force (in %) in Puerto Rico in 1999 to that in 2001?
Ensure brevity in your answer.  1.04. What is the ratio of the Total Labor Force (in %) in Channel Islands in 2000 to that in 2001?
Offer a terse response. 1. What is the ratio of the Total Labor Force (in %) in Cuba in 2000 to that in 2001?
Give a very brief answer. 1.03. What is the ratio of the Total Labor Force (in %) in Macao in 2000 to that in 2001?
Provide a succinct answer. 0.96. What is the ratio of the Total Labor Force (in %) of Puerto Rico in 2000 to that in 2001?
Your answer should be very brief. 0.99. What is the difference between the highest and the second highest Total Labor Force (in %) of Channel Islands?
Offer a very short reply. 0.4. What is the difference between the highest and the second highest Total Labor Force (in %) in Cuba?
Offer a terse response. 0.3. What is the difference between the highest and the second highest Total Labor Force (in %) of Puerto Rico?
Your answer should be compact. 0. What is the difference between the highest and the lowest Total Labor Force (in %) of Macao?
Offer a terse response. 10.9. What is the difference between the highest and the lowest Total Labor Force (in %) in Puerto Rico?
Keep it short and to the point. 4.2. 